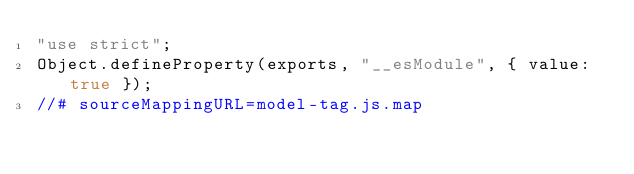<code> <loc_0><loc_0><loc_500><loc_500><_JavaScript_>"use strict";
Object.defineProperty(exports, "__esModule", { value: true });
//# sourceMappingURL=model-tag.js.map</code> 